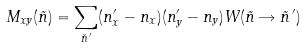<formula> <loc_0><loc_0><loc_500><loc_500>M _ { x y } ( \vec { n } ) = \sum _ { \vec { n } ^ { \, \prime } } ( n ^ { \prime } _ { x } - n _ { x } ) ( n ^ { \prime } _ { y } - n _ { y } ) W ( \vec { n } \rightarrow \vec { n } ^ { \, \prime } )</formula> 